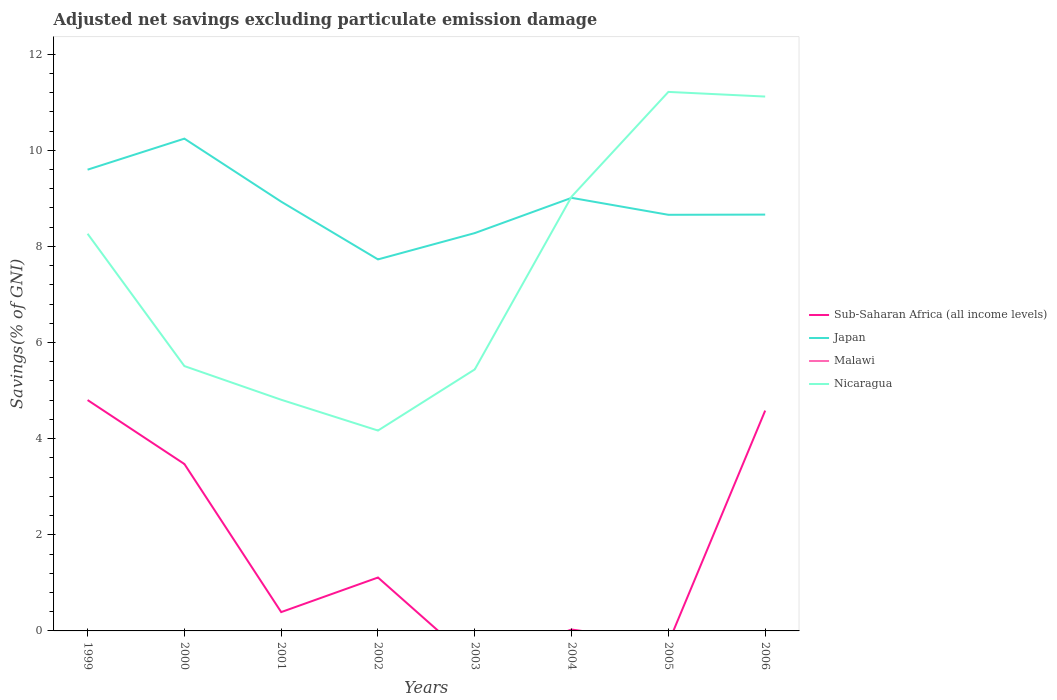How many different coloured lines are there?
Keep it short and to the point. 3. Does the line corresponding to Sub-Saharan Africa (all income levels) intersect with the line corresponding to Malawi?
Your response must be concise. No. Is the number of lines equal to the number of legend labels?
Offer a very short reply. No. Across all years, what is the maximum adjusted net savings in Sub-Saharan Africa (all income levels)?
Keep it short and to the point. 0. What is the total adjusted net savings in Japan in the graph?
Offer a terse response. 0.59. What is the difference between the highest and the second highest adjusted net savings in Japan?
Give a very brief answer. 2.51. Is the adjusted net savings in Nicaragua strictly greater than the adjusted net savings in Japan over the years?
Provide a succinct answer. No. How are the legend labels stacked?
Your answer should be compact. Vertical. What is the title of the graph?
Provide a short and direct response. Adjusted net savings excluding particulate emission damage. Does "Trinidad and Tobago" appear as one of the legend labels in the graph?
Keep it short and to the point. No. What is the label or title of the Y-axis?
Your answer should be compact. Savings(% of GNI). What is the Savings(% of GNI) in Sub-Saharan Africa (all income levels) in 1999?
Give a very brief answer. 4.8. What is the Savings(% of GNI) in Japan in 1999?
Keep it short and to the point. 9.6. What is the Savings(% of GNI) in Malawi in 1999?
Ensure brevity in your answer.  0. What is the Savings(% of GNI) in Nicaragua in 1999?
Your answer should be very brief. 8.26. What is the Savings(% of GNI) of Sub-Saharan Africa (all income levels) in 2000?
Offer a very short reply. 3.47. What is the Savings(% of GNI) of Japan in 2000?
Make the answer very short. 10.24. What is the Savings(% of GNI) in Malawi in 2000?
Your answer should be compact. 0. What is the Savings(% of GNI) in Nicaragua in 2000?
Offer a very short reply. 5.51. What is the Savings(% of GNI) in Sub-Saharan Africa (all income levels) in 2001?
Provide a short and direct response. 0.39. What is the Savings(% of GNI) of Japan in 2001?
Your response must be concise. 8.93. What is the Savings(% of GNI) in Malawi in 2001?
Offer a very short reply. 0. What is the Savings(% of GNI) of Nicaragua in 2001?
Offer a very short reply. 4.81. What is the Savings(% of GNI) of Sub-Saharan Africa (all income levels) in 2002?
Provide a succinct answer. 1.11. What is the Savings(% of GNI) in Japan in 2002?
Your response must be concise. 7.73. What is the Savings(% of GNI) of Malawi in 2002?
Your answer should be compact. 0. What is the Savings(% of GNI) of Nicaragua in 2002?
Keep it short and to the point. 4.17. What is the Savings(% of GNI) in Japan in 2003?
Your answer should be very brief. 8.28. What is the Savings(% of GNI) in Nicaragua in 2003?
Offer a very short reply. 5.44. What is the Savings(% of GNI) in Sub-Saharan Africa (all income levels) in 2004?
Keep it short and to the point. 0.03. What is the Savings(% of GNI) of Japan in 2004?
Provide a short and direct response. 9.01. What is the Savings(% of GNI) in Nicaragua in 2004?
Ensure brevity in your answer.  9.04. What is the Savings(% of GNI) of Japan in 2005?
Keep it short and to the point. 8.66. What is the Savings(% of GNI) of Nicaragua in 2005?
Make the answer very short. 11.21. What is the Savings(% of GNI) of Sub-Saharan Africa (all income levels) in 2006?
Your response must be concise. 4.58. What is the Savings(% of GNI) in Japan in 2006?
Make the answer very short. 8.66. What is the Savings(% of GNI) of Malawi in 2006?
Keep it short and to the point. 0. What is the Savings(% of GNI) in Nicaragua in 2006?
Your response must be concise. 11.12. Across all years, what is the maximum Savings(% of GNI) in Sub-Saharan Africa (all income levels)?
Give a very brief answer. 4.8. Across all years, what is the maximum Savings(% of GNI) of Japan?
Your answer should be compact. 10.24. Across all years, what is the maximum Savings(% of GNI) in Nicaragua?
Your response must be concise. 11.21. Across all years, what is the minimum Savings(% of GNI) of Japan?
Your answer should be very brief. 7.73. Across all years, what is the minimum Savings(% of GNI) of Nicaragua?
Keep it short and to the point. 4.17. What is the total Savings(% of GNI) in Sub-Saharan Africa (all income levels) in the graph?
Keep it short and to the point. 14.39. What is the total Savings(% of GNI) in Japan in the graph?
Your answer should be very brief. 71.11. What is the total Savings(% of GNI) of Malawi in the graph?
Ensure brevity in your answer.  0. What is the total Savings(% of GNI) in Nicaragua in the graph?
Provide a short and direct response. 59.56. What is the difference between the Savings(% of GNI) of Sub-Saharan Africa (all income levels) in 1999 and that in 2000?
Your answer should be compact. 1.33. What is the difference between the Savings(% of GNI) in Japan in 1999 and that in 2000?
Ensure brevity in your answer.  -0.65. What is the difference between the Savings(% of GNI) in Nicaragua in 1999 and that in 2000?
Your response must be concise. 2.75. What is the difference between the Savings(% of GNI) of Sub-Saharan Africa (all income levels) in 1999 and that in 2001?
Your answer should be compact. 4.41. What is the difference between the Savings(% of GNI) in Japan in 1999 and that in 2001?
Provide a short and direct response. 0.67. What is the difference between the Savings(% of GNI) of Nicaragua in 1999 and that in 2001?
Offer a terse response. 3.45. What is the difference between the Savings(% of GNI) in Sub-Saharan Africa (all income levels) in 1999 and that in 2002?
Ensure brevity in your answer.  3.69. What is the difference between the Savings(% of GNI) in Japan in 1999 and that in 2002?
Your response must be concise. 1.87. What is the difference between the Savings(% of GNI) of Nicaragua in 1999 and that in 2002?
Ensure brevity in your answer.  4.09. What is the difference between the Savings(% of GNI) of Japan in 1999 and that in 2003?
Keep it short and to the point. 1.32. What is the difference between the Savings(% of GNI) of Nicaragua in 1999 and that in 2003?
Offer a terse response. 2.82. What is the difference between the Savings(% of GNI) of Sub-Saharan Africa (all income levels) in 1999 and that in 2004?
Offer a very short reply. 4.77. What is the difference between the Savings(% of GNI) of Japan in 1999 and that in 2004?
Your answer should be very brief. 0.59. What is the difference between the Savings(% of GNI) of Nicaragua in 1999 and that in 2004?
Give a very brief answer. -0.77. What is the difference between the Savings(% of GNI) of Japan in 1999 and that in 2005?
Provide a succinct answer. 0.94. What is the difference between the Savings(% of GNI) of Nicaragua in 1999 and that in 2005?
Ensure brevity in your answer.  -2.95. What is the difference between the Savings(% of GNI) in Sub-Saharan Africa (all income levels) in 1999 and that in 2006?
Your answer should be compact. 0.22. What is the difference between the Savings(% of GNI) of Japan in 1999 and that in 2006?
Provide a succinct answer. 0.93. What is the difference between the Savings(% of GNI) in Nicaragua in 1999 and that in 2006?
Provide a short and direct response. -2.85. What is the difference between the Savings(% of GNI) in Sub-Saharan Africa (all income levels) in 2000 and that in 2001?
Your response must be concise. 3.08. What is the difference between the Savings(% of GNI) in Japan in 2000 and that in 2001?
Offer a terse response. 1.31. What is the difference between the Savings(% of GNI) in Nicaragua in 2000 and that in 2001?
Keep it short and to the point. 0.7. What is the difference between the Savings(% of GNI) in Sub-Saharan Africa (all income levels) in 2000 and that in 2002?
Your answer should be compact. 2.36. What is the difference between the Savings(% of GNI) of Japan in 2000 and that in 2002?
Offer a terse response. 2.51. What is the difference between the Savings(% of GNI) of Nicaragua in 2000 and that in 2002?
Your answer should be very brief. 1.34. What is the difference between the Savings(% of GNI) in Japan in 2000 and that in 2003?
Your response must be concise. 1.97. What is the difference between the Savings(% of GNI) of Nicaragua in 2000 and that in 2003?
Give a very brief answer. 0.07. What is the difference between the Savings(% of GNI) of Sub-Saharan Africa (all income levels) in 2000 and that in 2004?
Your answer should be very brief. 3.44. What is the difference between the Savings(% of GNI) in Japan in 2000 and that in 2004?
Offer a terse response. 1.23. What is the difference between the Savings(% of GNI) in Nicaragua in 2000 and that in 2004?
Keep it short and to the point. -3.52. What is the difference between the Savings(% of GNI) of Japan in 2000 and that in 2005?
Keep it short and to the point. 1.58. What is the difference between the Savings(% of GNI) in Nicaragua in 2000 and that in 2005?
Your response must be concise. -5.7. What is the difference between the Savings(% of GNI) of Sub-Saharan Africa (all income levels) in 2000 and that in 2006?
Give a very brief answer. -1.11. What is the difference between the Savings(% of GNI) in Japan in 2000 and that in 2006?
Keep it short and to the point. 1.58. What is the difference between the Savings(% of GNI) in Nicaragua in 2000 and that in 2006?
Ensure brevity in your answer.  -5.61. What is the difference between the Savings(% of GNI) of Sub-Saharan Africa (all income levels) in 2001 and that in 2002?
Offer a terse response. -0.72. What is the difference between the Savings(% of GNI) in Japan in 2001 and that in 2002?
Ensure brevity in your answer.  1.2. What is the difference between the Savings(% of GNI) of Nicaragua in 2001 and that in 2002?
Offer a very short reply. 0.64. What is the difference between the Savings(% of GNI) in Japan in 2001 and that in 2003?
Your answer should be very brief. 0.65. What is the difference between the Savings(% of GNI) in Nicaragua in 2001 and that in 2003?
Make the answer very short. -0.63. What is the difference between the Savings(% of GNI) in Sub-Saharan Africa (all income levels) in 2001 and that in 2004?
Offer a very short reply. 0.36. What is the difference between the Savings(% of GNI) in Japan in 2001 and that in 2004?
Provide a succinct answer. -0.08. What is the difference between the Savings(% of GNI) of Nicaragua in 2001 and that in 2004?
Offer a terse response. -4.23. What is the difference between the Savings(% of GNI) of Japan in 2001 and that in 2005?
Provide a succinct answer. 0.27. What is the difference between the Savings(% of GNI) of Nicaragua in 2001 and that in 2005?
Your answer should be compact. -6.4. What is the difference between the Savings(% of GNI) of Sub-Saharan Africa (all income levels) in 2001 and that in 2006?
Provide a short and direct response. -4.19. What is the difference between the Savings(% of GNI) of Japan in 2001 and that in 2006?
Offer a very short reply. 0.27. What is the difference between the Savings(% of GNI) in Nicaragua in 2001 and that in 2006?
Keep it short and to the point. -6.31. What is the difference between the Savings(% of GNI) in Japan in 2002 and that in 2003?
Ensure brevity in your answer.  -0.55. What is the difference between the Savings(% of GNI) in Nicaragua in 2002 and that in 2003?
Your answer should be very brief. -1.27. What is the difference between the Savings(% of GNI) of Sub-Saharan Africa (all income levels) in 2002 and that in 2004?
Give a very brief answer. 1.08. What is the difference between the Savings(% of GNI) of Japan in 2002 and that in 2004?
Ensure brevity in your answer.  -1.28. What is the difference between the Savings(% of GNI) in Nicaragua in 2002 and that in 2004?
Ensure brevity in your answer.  -4.87. What is the difference between the Savings(% of GNI) in Japan in 2002 and that in 2005?
Ensure brevity in your answer.  -0.93. What is the difference between the Savings(% of GNI) of Nicaragua in 2002 and that in 2005?
Offer a terse response. -7.05. What is the difference between the Savings(% of GNI) of Sub-Saharan Africa (all income levels) in 2002 and that in 2006?
Provide a short and direct response. -3.47. What is the difference between the Savings(% of GNI) of Japan in 2002 and that in 2006?
Your response must be concise. -0.93. What is the difference between the Savings(% of GNI) of Nicaragua in 2002 and that in 2006?
Your answer should be very brief. -6.95. What is the difference between the Savings(% of GNI) of Japan in 2003 and that in 2004?
Offer a terse response. -0.73. What is the difference between the Savings(% of GNI) of Nicaragua in 2003 and that in 2004?
Offer a terse response. -3.59. What is the difference between the Savings(% of GNI) of Japan in 2003 and that in 2005?
Give a very brief answer. -0.38. What is the difference between the Savings(% of GNI) in Nicaragua in 2003 and that in 2005?
Make the answer very short. -5.77. What is the difference between the Savings(% of GNI) in Japan in 2003 and that in 2006?
Offer a terse response. -0.38. What is the difference between the Savings(% of GNI) in Nicaragua in 2003 and that in 2006?
Offer a very short reply. -5.68. What is the difference between the Savings(% of GNI) of Japan in 2004 and that in 2005?
Keep it short and to the point. 0.35. What is the difference between the Savings(% of GNI) in Nicaragua in 2004 and that in 2005?
Keep it short and to the point. -2.18. What is the difference between the Savings(% of GNI) of Sub-Saharan Africa (all income levels) in 2004 and that in 2006?
Your response must be concise. -4.56. What is the difference between the Savings(% of GNI) in Japan in 2004 and that in 2006?
Provide a short and direct response. 0.35. What is the difference between the Savings(% of GNI) of Nicaragua in 2004 and that in 2006?
Make the answer very short. -2.08. What is the difference between the Savings(% of GNI) of Japan in 2005 and that in 2006?
Provide a succinct answer. -0. What is the difference between the Savings(% of GNI) in Nicaragua in 2005 and that in 2006?
Offer a terse response. 0.1. What is the difference between the Savings(% of GNI) of Sub-Saharan Africa (all income levels) in 1999 and the Savings(% of GNI) of Japan in 2000?
Provide a short and direct response. -5.44. What is the difference between the Savings(% of GNI) in Sub-Saharan Africa (all income levels) in 1999 and the Savings(% of GNI) in Nicaragua in 2000?
Make the answer very short. -0.71. What is the difference between the Savings(% of GNI) in Japan in 1999 and the Savings(% of GNI) in Nicaragua in 2000?
Ensure brevity in your answer.  4.09. What is the difference between the Savings(% of GNI) of Sub-Saharan Africa (all income levels) in 1999 and the Savings(% of GNI) of Japan in 2001?
Provide a short and direct response. -4.13. What is the difference between the Savings(% of GNI) in Sub-Saharan Africa (all income levels) in 1999 and the Savings(% of GNI) in Nicaragua in 2001?
Your answer should be compact. -0.01. What is the difference between the Savings(% of GNI) of Japan in 1999 and the Savings(% of GNI) of Nicaragua in 2001?
Make the answer very short. 4.79. What is the difference between the Savings(% of GNI) of Sub-Saharan Africa (all income levels) in 1999 and the Savings(% of GNI) of Japan in 2002?
Provide a short and direct response. -2.93. What is the difference between the Savings(% of GNI) of Sub-Saharan Africa (all income levels) in 1999 and the Savings(% of GNI) of Nicaragua in 2002?
Your answer should be very brief. 0.63. What is the difference between the Savings(% of GNI) in Japan in 1999 and the Savings(% of GNI) in Nicaragua in 2002?
Give a very brief answer. 5.43. What is the difference between the Savings(% of GNI) in Sub-Saharan Africa (all income levels) in 1999 and the Savings(% of GNI) in Japan in 2003?
Make the answer very short. -3.47. What is the difference between the Savings(% of GNI) in Sub-Saharan Africa (all income levels) in 1999 and the Savings(% of GNI) in Nicaragua in 2003?
Keep it short and to the point. -0.64. What is the difference between the Savings(% of GNI) in Japan in 1999 and the Savings(% of GNI) in Nicaragua in 2003?
Make the answer very short. 4.16. What is the difference between the Savings(% of GNI) in Sub-Saharan Africa (all income levels) in 1999 and the Savings(% of GNI) in Japan in 2004?
Ensure brevity in your answer.  -4.21. What is the difference between the Savings(% of GNI) in Sub-Saharan Africa (all income levels) in 1999 and the Savings(% of GNI) in Nicaragua in 2004?
Give a very brief answer. -4.23. What is the difference between the Savings(% of GNI) of Japan in 1999 and the Savings(% of GNI) of Nicaragua in 2004?
Make the answer very short. 0.56. What is the difference between the Savings(% of GNI) in Sub-Saharan Africa (all income levels) in 1999 and the Savings(% of GNI) in Japan in 2005?
Provide a short and direct response. -3.85. What is the difference between the Savings(% of GNI) in Sub-Saharan Africa (all income levels) in 1999 and the Savings(% of GNI) in Nicaragua in 2005?
Your answer should be very brief. -6.41. What is the difference between the Savings(% of GNI) of Japan in 1999 and the Savings(% of GNI) of Nicaragua in 2005?
Make the answer very short. -1.62. What is the difference between the Savings(% of GNI) of Sub-Saharan Africa (all income levels) in 1999 and the Savings(% of GNI) of Japan in 2006?
Provide a short and direct response. -3.86. What is the difference between the Savings(% of GNI) of Sub-Saharan Africa (all income levels) in 1999 and the Savings(% of GNI) of Nicaragua in 2006?
Offer a very short reply. -6.31. What is the difference between the Savings(% of GNI) of Japan in 1999 and the Savings(% of GNI) of Nicaragua in 2006?
Make the answer very short. -1.52. What is the difference between the Savings(% of GNI) in Sub-Saharan Africa (all income levels) in 2000 and the Savings(% of GNI) in Japan in 2001?
Your response must be concise. -5.46. What is the difference between the Savings(% of GNI) of Sub-Saharan Africa (all income levels) in 2000 and the Savings(% of GNI) of Nicaragua in 2001?
Provide a short and direct response. -1.34. What is the difference between the Savings(% of GNI) of Japan in 2000 and the Savings(% of GNI) of Nicaragua in 2001?
Offer a terse response. 5.43. What is the difference between the Savings(% of GNI) in Sub-Saharan Africa (all income levels) in 2000 and the Savings(% of GNI) in Japan in 2002?
Your answer should be very brief. -4.26. What is the difference between the Savings(% of GNI) of Sub-Saharan Africa (all income levels) in 2000 and the Savings(% of GNI) of Nicaragua in 2002?
Ensure brevity in your answer.  -0.7. What is the difference between the Savings(% of GNI) in Japan in 2000 and the Savings(% of GNI) in Nicaragua in 2002?
Keep it short and to the point. 6.07. What is the difference between the Savings(% of GNI) of Sub-Saharan Africa (all income levels) in 2000 and the Savings(% of GNI) of Japan in 2003?
Give a very brief answer. -4.8. What is the difference between the Savings(% of GNI) in Sub-Saharan Africa (all income levels) in 2000 and the Savings(% of GNI) in Nicaragua in 2003?
Keep it short and to the point. -1.97. What is the difference between the Savings(% of GNI) of Japan in 2000 and the Savings(% of GNI) of Nicaragua in 2003?
Your answer should be very brief. 4.8. What is the difference between the Savings(% of GNI) in Sub-Saharan Africa (all income levels) in 2000 and the Savings(% of GNI) in Japan in 2004?
Your answer should be very brief. -5.54. What is the difference between the Savings(% of GNI) in Sub-Saharan Africa (all income levels) in 2000 and the Savings(% of GNI) in Nicaragua in 2004?
Your answer should be compact. -5.56. What is the difference between the Savings(% of GNI) of Japan in 2000 and the Savings(% of GNI) of Nicaragua in 2004?
Give a very brief answer. 1.21. What is the difference between the Savings(% of GNI) in Sub-Saharan Africa (all income levels) in 2000 and the Savings(% of GNI) in Japan in 2005?
Offer a terse response. -5.18. What is the difference between the Savings(% of GNI) of Sub-Saharan Africa (all income levels) in 2000 and the Savings(% of GNI) of Nicaragua in 2005?
Your response must be concise. -7.74. What is the difference between the Savings(% of GNI) in Japan in 2000 and the Savings(% of GNI) in Nicaragua in 2005?
Give a very brief answer. -0.97. What is the difference between the Savings(% of GNI) in Sub-Saharan Africa (all income levels) in 2000 and the Savings(% of GNI) in Japan in 2006?
Your response must be concise. -5.19. What is the difference between the Savings(% of GNI) in Sub-Saharan Africa (all income levels) in 2000 and the Savings(% of GNI) in Nicaragua in 2006?
Provide a succinct answer. -7.64. What is the difference between the Savings(% of GNI) in Japan in 2000 and the Savings(% of GNI) in Nicaragua in 2006?
Make the answer very short. -0.88. What is the difference between the Savings(% of GNI) of Sub-Saharan Africa (all income levels) in 2001 and the Savings(% of GNI) of Japan in 2002?
Ensure brevity in your answer.  -7.34. What is the difference between the Savings(% of GNI) in Sub-Saharan Africa (all income levels) in 2001 and the Savings(% of GNI) in Nicaragua in 2002?
Your answer should be compact. -3.78. What is the difference between the Savings(% of GNI) of Japan in 2001 and the Savings(% of GNI) of Nicaragua in 2002?
Offer a terse response. 4.76. What is the difference between the Savings(% of GNI) of Sub-Saharan Africa (all income levels) in 2001 and the Savings(% of GNI) of Japan in 2003?
Your answer should be very brief. -7.89. What is the difference between the Savings(% of GNI) of Sub-Saharan Africa (all income levels) in 2001 and the Savings(% of GNI) of Nicaragua in 2003?
Offer a terse response. -5.05. What is the difference between the Savings(% of GNI) in Japan in 2001 and the Savings(% of GNI) in Nicaragua in 2003?
Make the answer very short. 3.49. What is the difference between the Savings(% of GNI) of Sub-Saharan Africa (all income levels) in 2001 and the Savings(% of GNI) of Japan in 2004?
Your answer should be compact. -8.62. What is the difference between the Savings(% of GNI) of Sub-Saharan Africa (all income levels) in 2001 and the Savings(% of GNI) of Nicaragua in 2004?
Keep it short and to the point. -8.64. What is the difference between the Savings(% of GNI) of Japan in 2001 and the Savings(% of GNI) of Nicaragua in 2004?
Your answer should be very brief. -0.1. What is the difference between the Savings(% of GNI) in Sub-Saharan Africa (all income levels) in 2001 and the Savings(% of GNI) in Japan in 2005?
Ensure brevity in your answer.  -8.27. What is the difference between the Savings(% of GNI) of Sub-Saharan Africa (all income levels) in 2001 and the Savings(% of GNI) of Nicaragua in 2005?
Give a very brief answer. -10.82. What is the difference between the Savings(% of GNI) of Japan in 2001 and the Savings(% of GNI) of Nicaragua in 2005?
Provide a short and direct response. -2.28. What is the difference between the Savings(% of GNI) in Sub-Saharan Africa (all income levels) in 2001 and the Savings(% of GNI) in Japan in 2006?
Your answer should be compact. -8.27. What is the difference between the Savings(% of GNI) in Sub-Saharan Africa (all income levels) in 2001 and the Savings(% of GNI) in Nicaragua in 2006?
Provide a short and direct response. -10.73. What is the difference between the Savings(% of GNI) in Japan in 2001 and the Savings(% of GNI) in Nicaragua in 2006?
Provide a succinct answer. -2.19. What is the difference between the Savings(% of GNI) in Sub-Saharan Africa (all income levels) in 2002 and the Savings(% of GNI) in Japan in 2003?
Make the answer very short. -7.17. What is the difference between the Savings(% of GNI) in Sub-Saharan Africa (all income levels) in 2002 and the Savings(% of GNI) in Nicaragua in 2003?
Your response must be concise. -4.33. What is the difference between the Savings(% of GNI) of Japan in 2002 and the Savings(% of GNI) of Nicaragua in 2003?
Your answer should be very brief. 2.29. What is the difference between the Savings(% of GNI) in Sub-Saharan Africa (all income levels) in 2002 and the Savings(% of GNI) in Japan in 2004?
Give a very brief answer. -7.9. What is the difference between the Savings(% of GNI) of Sub-Saharan Africa (all income levels) in 2002 and the Savings(% of GNI) of Nicaragua in 2004?
Ensure brevity in your answer.  -7.92. What is the difference between the Savings(% of GNI) in Japan in 2002 and the Savings(% of GNI) in Nicaragua in 2004?
Offer a terse response. -1.31. What is the difference between the Savings(% of GNI) of Sub-Saharan Africa (all income levels) in 2002 and the Savings(% of GNI) of Japan in 2005?
Provide a succinct answer. -7.55. What is the difference between the Savings(% of GNI) of Sub-Saharan Africa (all income levels) in 2002 and the Savings(% of GNI) of Nicaragua in 2005?
Give a very brief answer. -10.1. What is the difference between the Savings(% of GNI) in Japan in 2002 and the Savings(% of GNI) in Nicaragua in 2005?
Your response must be concise. -3.48. What is the difference between the Savings(% of GNI) of Sub-Saharan Africa (all income levels) in 2002 and the Savings(% of GNI) of Japan in 2006?
Provide a succinct answer. -7.55. What is the difference between the Savings(% of GNI) in Sub-Saharan Africa (all income levels) in 2002 and the Savings(% of GNI) in Nicaragua in 2006?
Your answer should be very brief. -10.01. What is the difference between the Savings(% of GNI) of Japan in 2002 and the Savings(% of GNI) of Nicaragua in 2006?
Make the answer very short. -3.39. What is the difference between the Savings(% of GNI) of Japan in 2003 and the Savings(% of GNI) of Nicaragua in 2004?
Your response must be concise. -0.76. What is the difference between the Savings(% of GNI) of Japan in 2003 and the Savings(% of GNI) of Nicaragua in 2005?
Your answer should be compact. -2.94. What is the difference between the Savings(% of GNI) of Japan in 2003 and the Savings(% of GNI) of Nicaragua in 2006?
Keep it short and to the point. -2.84. What is the difference between the Savings(% of GNI) in Sub-Saharan Africa (all income levels) in 2004 and the Savings(% of GNI) in Japan in 2005?
Give a very brief answer. -8.63. What is the difference between the Savings(% of GNI) of Sub-Saharan Africa (all income levels) in 2004 and the Savings(% of GNI) of Nicaragua in 2005?
Provide a short and direct response. -11.19. What is the difference between the Savings(% of GNI) of Japan in 2004 and the Savings(% of GNI) of Nicaragua in 2005?
Offer a very short reply. -2.2. What is the difference between the Savings(% of GNI) of Sub-Saharan Africa (all income levels) in 2004 and the Savings(% of GNI) of Japan in 2006?
Make the answer very short. -8.63. What is the difference between the Savings(% of GNI) of Sub-Saharan Africa (all income levels) in 2004 and the Savings(% of GNI) of Nicaragua in 2006?
Offer a terse response. -11.09. What is the difference between the Savings(% of GNI) of Japan in 2004 and the Savings(% of GNI) of Nicaragua in 2006?
Provide a short and direct response. -2.11. What is the difference between the Savings(% of GNI) in Japan in 2005 and the Savings(% of GNI) in Nicaragua in 2006?
Ensure brevity in your answer.  -2.46. What is the average Savings(% of GNI) of Sub-Saharan Africa (all income levels) per year?
Your response must be concise. 1.8. What is the average Savings(% of GNI) in Japan per year?
Offer a very short reply. 8.89. What is the average Savings(% of GNI) of Malawi per year?
Your answer should be compact. 0. What is the average Savings(% of GNI) of Nicaragua per year?
Offer a very short reply. 7.45. In the year 1999, what is the difference between the Savings(% of GNI) in Sub-Saharan Africa (all income levels) and Savings(% of GNI) in Japan?
Ensure brevity in your answer.  -4.79. In the year 1999, what is the difference between the Savings(% of GNI) in Sub-Saharan Africa (all income levels) and Savings(% of GNI) in Nicaragua?
Make the answer very short. -3.46. In the year 1999, what is the difference between the Savings(% of GNI) in Japan and Savings(% of GNI) in Nicaragua?
Give a very brief answer. 1.33. In the year 2000, what is the difference between the Savings(% of GNI) of Sub-Saharan Africa (all income levels) and Savings(% of GNI) of Japan?
Make the answer very short. -6.77. In the year 2000, what is the difference between the Savings(% of GNI) of Sub-Saharan Africa (all income levels) and Savings(% of GNI) of Nicaragua?
Your response must be concise. -2.04. In the year 2000, what is the difference between the Savings(% of GNI) of Japan and Savings(% of GNI) of Nicaragua?
Offer a very short reply. 4.73. In the year 2001, what is the difference between the Savings(% of GNI) in Sub-Saharan Africa (all income levels) and Savings(% of GNI) in Japan?
Offer a terse response. -8.54. In the year 2001, what is the difference between the Savings(% of GNI) in Sub-Saharan Africa (all income levels) and Savings(% of GNI) in Nicaragua?
Make the answer very short. -4.42. In the year 2001, what is the difference between the Savings(% of GNI) of Japan and Savings(% of GNI) of Nicaragua?
Your answer should be very brief. 4.12. In the year 2002, what is the difference between the Savings(% of GNI) of Sub-Saharan Africa (all income levels) and Savings(% of GNI) of Japan?
Ensure brevity in your answer.  -6.62. In the year 2002, what is the difference between the Savings(% of GNI) of Sub-Saharan Africa (all income levels) and Savings(% of GNI) of Nicaragua?
Your answer should be compact. -3.06. In the year 2002, what is the difference between the Savings(% of GNI) in Japan and Savings(% of GNI) in Nicaragua?
Ensure brevity in your answer.  3.56. In the year 2003, what is the difference between the Savings(% of GNI) in Japan and Savings(% of GNI) in Nicaragua?
Provide a succinct answer. 2.84. In the year 2004, what is the difference between the Savings(% of GNI) in Sub-Saharan Africa (all income levels) and Savings(% of GNI) in Japan?
Your answer should be compact. -8.98. In the year 2004, what is the difference between the Savings(% of GNI) in Sub-Saharan Africa (all income levels) and Savings(% of GNI) in Nicaragua?
Offer a terse response. -9.01. In the year 2004, what is the difference between the Savings(% of GNI) in Japan and Savings(% of GNI) in Nicaragua?
Ensure brevity in your answer.  -0.02. In the year 2005, what is the difference between the Savings(% of GNI) of Japan and Savings(% of GNI) of Nicaragua?
Offer a terse response. -2.56. In the year 2006, what is the difference between the Savings(% of GNI) of Sub-Saharan Africa (all income levels) and Savings(% of GNI) of Japan?
Give a very brief answer. -4.08. In the year 2006, what is the difference between the Savings(% of GNI) in Sub-Saharan Africa (all income levels) and Savings(% of GNI) in Nicaragua?
Offer a terse response. -6.53. In the year 2006, what is the difference between the Savings(% of GNI) of Japan and Savings(% of GNI) of Nicaragua?
Give a very brief answer. -2.46. What is the ratio of the Savings(% of GNI) of Sub-Saharan Africa (all income levels) in 1999 to that in 2000?
Your response must be concise. 1.38. What is the ratio of the Savings(% of GNI) of Japan in 1999 to that in 2000?
Provide a short and direct response. 0.94. What is the ratio of the Savings(% of GNI) of Nicaragua in 1999 to that in 2000?
Your answer should be very brief. 1.5. What is the ratio of the Savings(% of GNI) of Sub-Saharan Africa (all income levels) in 1999 to that in 2001?
Make the answer very short. 12.26. What is the ratio of the Savings(% of GNI) of Japan in 1999 to that in 2001?
Your answer should be compact. 1.07. What is the ratio of the Savings(% of GNI) in Nicaragua in 1999 to that in 2001?
Keep it short and to the point. 1.72. What is the ratio of the Savings(% of GNI) in Sub-Saharan Africa (all income levels) in 1999 to that in 2002?
Your answer should be compact. 4.32. What is the ratio of the Savings(% of GNI) in Japan in 1999 to that in 2002?
Keep it short and to the point. 1.24. What is the ratio of the Savings(% of GNI) of Nicaragua in 1999 to that in 2002?
Provide a short and direct response. 1.98. What is the ratio of the Savings(% of GNI) of Japan in 1999 to that in 2003?
Keep it short and to the point. 1.16. What is the ratio of the Savings(% of GNI) in Nicaragua in 1999 to that in 2003?
Give a very brief answer. 1.52. What is the ratio of the Savings(% of GNI) in Sub-Saharan Africa (all income levels) in 1999 to that in 2004?
Provide a short and direct response. 168.95. What is the ratio of the Savings(% of GNI) of Japan in 1999 to that in 2004?
Make the answer very short. 1.06. What is the ratio of the Savings(% of GNI) in Nicaragua in 1999 to that in 2004?
Provide a short and direct response. 0.91. What is the ratio of the Savings(% of GNI) in Japan in 1999 to that in 2005?
Offer a very short reply. 1.11. What is the ratio of the Savings(% of GNI) of Nicaragua in 1999 to that in 2005?
Provide a short and direct response. 0.74. What is the ratio of the Savings(% of GNI) in Sub-Saharan Africa (all income levels) in 1999 to that in 2006?
Offer a terse response. 1.05. What is the ratio of the Savings(% of GNI) in Japan in 1999 to that in 2006?
Your answer should be very brief. 1.11. What is the ratio of the Savings(% of GNI) in Nicaragua in 1999 to that in 2006?
Offer a very short reply. 0.74. What is the ratio of the Savings(% of GNI) in Sub-Saharan Africa (all income levels) in 2000 to that in 2001?
Ensure brevity in your answer.  8.86. What is the ratio of the Savings(% of GNI) in Japan in 2000 to that in 2001?
Your answer should be very brief. 1.15. What is the ratio of the Savings(% of GNI) in Nicaragua in 2000 to that in 2001?
Keep it short and to the point. 1.15. What is the ratio of the Savings(% of GNI) in Sub-Saharan Africa (all income levels) in 2000 to that in 2002?
Your answer should be very brief. 3.13. What is the ratio of the Savings(% of GNI) of Japan in 2000 to that in 2002?
Your response must be concise. 1.33. What is the ratio of the Savings(% of GNI) of Nicaragua in 2000 to that in 2002?
Keep it short and to the point. 1.32. What is the ratio of the Savings(% of GNI) of Japan in 2000 to that in 2003?
Provide a succinct answer. 1.24. What is the ratio of the Savings(% of GNI) in Nicaragua in 2000 to that in 2003?
Provide a succinct answer. 1.01. What is the ratio of the Savings(% of GNI) in Sub-Saharan Africa (all income levels) in 2000 to that in 2004?
Keep it short and to the point. 122.15. What is the ratio of the Savings(% of GNI) in Japan in 2000 to that in 2004?
Your response must be concise. 1.14. What is the ratio of the Savings(% of GNI) of Nicaragua in 2000 to that in 2004?
Make the answer very short. 0.61. What is the ratio of the Savings(% of GNI) in Japan in 2000 to that in 2005?
Offer a terse response. 1.18. What is the ratio of the Savings(% of GNI) in Nicaragua in 2000 to that in 2005?
Your response must be concise. 0.49. What is the ratio of the Savings(% of GNI) of Sub-Saharan Africa (all income levels) in 2000 to that in 2006?
Your response must be concise. 0.76. What is the ratio of the Savings(% of GNI) of Japan in 2000 to that in 2006?
Ensure brevity in your answer.  1.18. What is the ratio of the Savings(% of GNI) in Nicaragua in 2000 to that in 2006?
Ensure brevity in your answer.  0.5. What is the ratio of the Savings(% of GNI) of Sub-Saharan Africa (all income levels) in 2001 to that in 2002?
Ensure brevity in your answer.  0.35. What is the ratio of the Savings(% of GNI) of Japan in 2001 to that in 2002?
Offer a terse response. 1.16. What is the ratio of the Savings(% of GNI) in Nicaragua in 2001 to that in 2002?
Provide a succinct answer. 1.15. What is the ratio of the Savings(% of GNI) in Japan in 2001 to that in 2003?
Keep it short and to the point. 1.08. What is the ratio of the Savings(% of GNI) in Nicaragua in 2001 to that in 2003?
Your answer should be very brief. 0.88. What is the ratio of the Savings(% of GNI) in Sub-Saharan Africa (all income levels) in 2001 to that in 2004?
Your answer should be compact. 13.78. What is the ratio of the Savings(% of GNI) of Nicaragua in 2001 to that in 2004?
Give a very brief answer. 0.53. What is the ratio of the Savings(% of GNI) in Japan in 2001 to that in 2005?
Offer a very short reply. 1.03. What is the ratio of the Savings(% of GNI) of Nicaragua in 2001 to that in 2005?
Your response must be concise. 0.43. What is the ratio of the Savings(% of GNI) in Sub-Saharan Africa (all income levels) in 2001 to that in 2006?
Your response must be concise. 0.09. What is the ratio of the Savings(% of GNI) in Japan in 2001 to that in 2006?
Provide a short and direct response. 1.03. What is the ratio of the Savings(% of GNI) of Nicaragua in 2001 to that in 2006?
Offer a very short reply. 0.43. What is the ratio of the Savings(% of GNI) of Japan in 2002 to that in 2003?
Make the answer very short. 0.93. What is the ratio of the Savings(% of GNI) in Nicaragua in 2002 to that in 2003?
Ensure brevity in your answer.  0.77. What is the ratio of the Savings(% of GNI) in Sub-Saharan Africa (all income levels) in 2002 to that in 2004?
Give a very brief answer. 39.08. What is the ratio of the Savings(% of GNI) of Japan in 2002 to that in 2004?
Give a very brief answer. 0.86. What is the ratio of the Savings(% of GNI) of Nicaragua in 2002 to that in 2004?
Ensure brevity in your answer.  0.46. What is the ratio of the Savings(% of GNI) of Japan in 2002 to that in 2005?
Offer a very short reply. 0.89. What is the ratio of the Savings(% of GNI) in Nicaragua in 2002 to that in 2005?
Provide a succinct answer. 0.37. What is the ratio of the Savings(% of GNI) of Sub-Saharan Africa (all income levels) in 2002 to that in 2006?
Your answer should be very brief. 0.24. What is the ratio of the Savings(% of GNI) of Japan in 2002 to that in 2006?
Provide a succinct answer. 0.89. What is the ratio of the Savings(% of GNI) in Nicaragua in 2002 to that in 2006?
Your response must be concise. 0.38. What is the ratio of the Savings(% of GNI) in Japan in 2003 to that in 2004?
Ensure brevity in your answer.  0.92. What is the ratio of the Savings(% of GNI) of Nicaragua in 2003 to that in 2004?
Ensure brevity in your answer.  0.6. What is the ratio of the Savings(% of GNI) in Japan in 2003 to that in 2005?
Offer a terse response. 0.96. What is the ratio of the Savings(% of GNI) of Nicaragua in 2003 to that in 2005?
Give a very brief answer. 0.49. What is the ratio of the Savings(% of GNI) of Japan in 2003 to that in 2006?
Provide a short and direct response. 0.96. What is the ratio of the Savings(% of GNI) of Nicaragua in 2003 to that in 2006?
Your answer should be very brief. 0.49. What is the ratio of the Savings(% of GNI) of Japan in 2004 to that in 2005?
Provide a short and direct response. 1.04. What is the ratio of the Savings(% of GNI) in Nicaragua in 2004 to that in 2005?
Your answer should be very brief. 0.81. What is the ratio of the Savings(% of GNI) in Sub-Saharan Africa (all income levels) in 2004 to that in 2006?
Your answer should be very brief. 0.01. What is the ratio of the Savings(% of GNI) in Japan in 2004 to that in 2006?
Give a very brief answer. 1.04. What is the ratio of the Savings(% of GNI) in Nicaragua in 2004 to that in 2006?
Make the answer very short. 0.81. What is the ratio of the Savings(% of GNI) in Japan in 2005 to that in 2006?
Offer a very short reply. 1. What is the ratio of the Savings(% of GNI) of Nicaragua in 2005 to that in 2006?
Your response must be concise. 1.01. What is the difference between the highest and the second highest Savings(% of GNI) in Sub-Saharan Africa (all income levels)?
Provide a succinct answer. 0.22. What is the difference between the highest and the second highest Savings(% of GNI) of Japan?
Your answer should be compact. 0.65. What is the difference between the highest and the second highest Savings(% of GNI) in Nicaragua?
Offer a very short reply. 0.1. What is the difference between the highest and the lowest Savings(% of GNI) of Sub-Saharan Africa (all income levels)?
Your response must be concise. 4.8. What is the difference between the highest and the lowest Savings(% of GNI) in Japan?
Provide a short and direct response. 2.51. What is the difference between the highest and the lowest Savings(% of GNI) of Nicaragua?
Offer a very short reply. 7.05. 